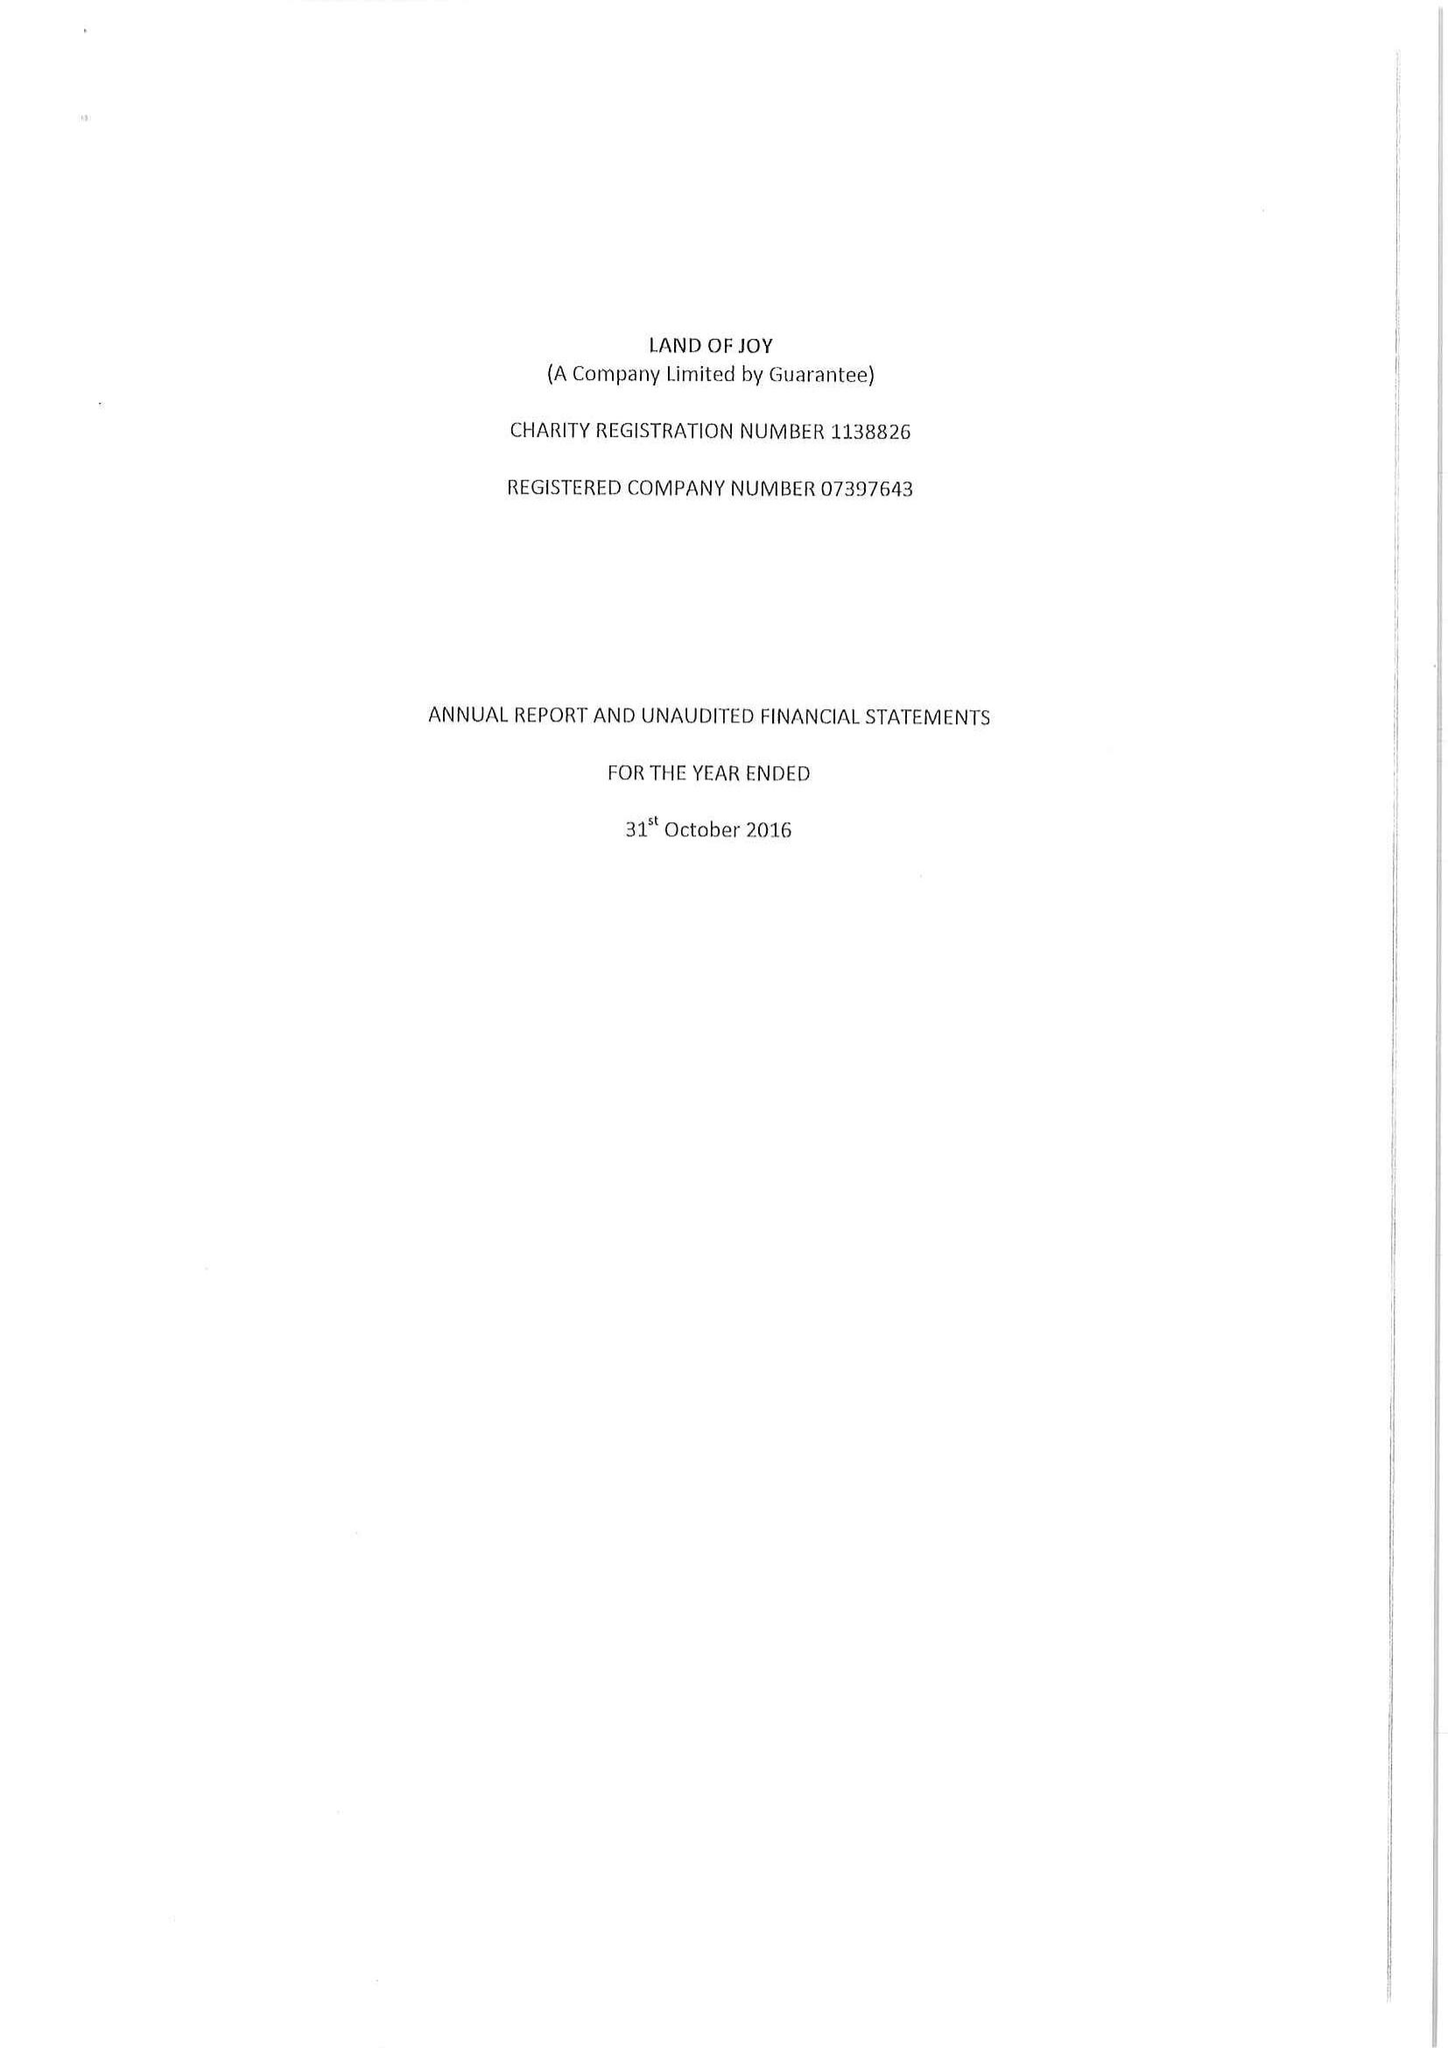What is the value for the income_annually_in_british_pounds?
Answer the question using a single word or phrase. 180559.00 